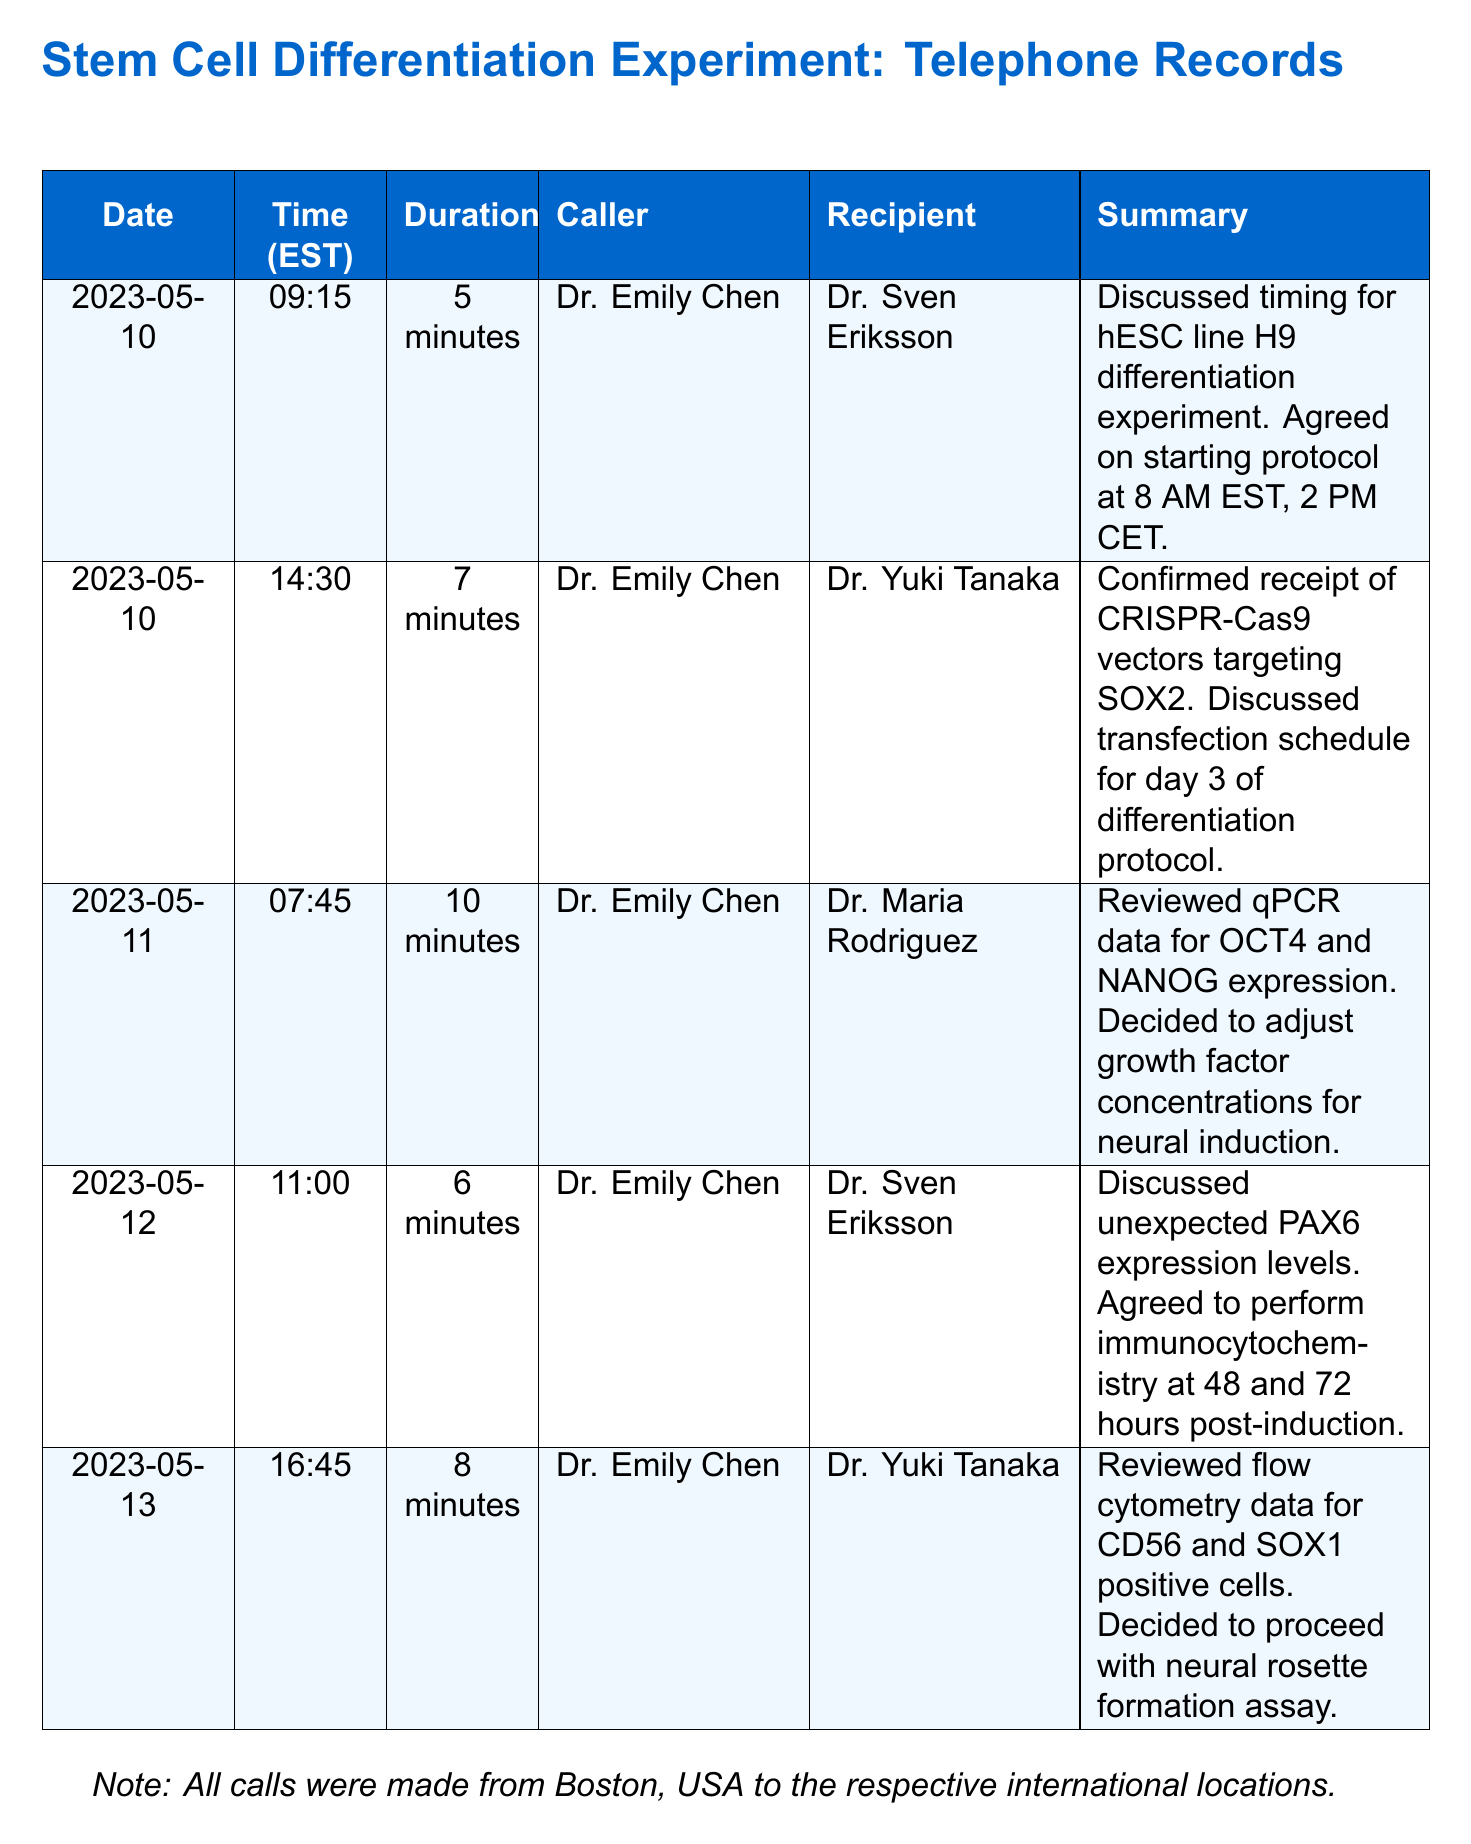What date was the first call made? The first call in the records was made on May 10, 2023.
Answer: May 10, 2023 Who spoke with Dr. Emily Chen on May 12? On May 12, Dr. Emily Chen spoke with Dr. Sven Eriksson as noted in the summary.
Answer: Dr. Sven Eriksson How long did the call on May 11 last? The duration of the call on May 11 was 10 minutes as stated in the records.
Answer: 10 minutes What topic was discussed during the call on May 10 with Dr. Sven Eriksson? The call on May 10 focused on the timing for the hESC line H9 differentiation experiment.
Answer: Timing for hESC line H9 differentiation experiment How many calls are recorded in total? There are five calls documented in the telephone records provided.
Answer: 5 What was adjusted based on the qPCR data review? The team decided to adjust growth factor concentrations for neural induction based on the qPCR data.
Answer: Growth factor concentrations Which experiment's protocol start time was agreed upon? The protocol for the hESC line H9 differentiation experiment was set to start at 8 AM EST.
Answer: 8 AM EST On which date did Dr. Emily Chen confirm receipt of vectors? The confirmation regarding the receipt of CRISPR-Cas9 vectors occurred on May 10, 2023.
Answer: May 10, 2023 What did the team decide to proceed with based on flow cytometry data? The team decided to proceed with the neural rosette formation assay based on the flow cytometry data.
Answer: Neural rosette formation assay 